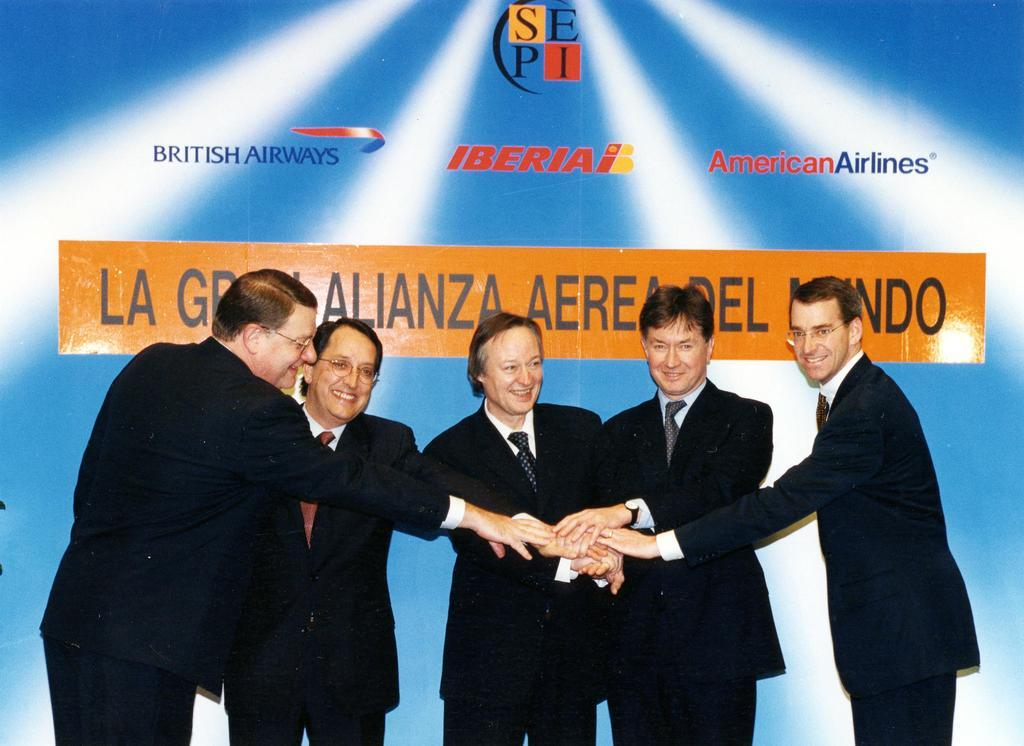What can be seen in the background of the image? There is a hoarding in the background of the image. What are the main subjects in the image? There are men standing in the image. Can you describe the appearance of some of the men? Some of the men are wearing spectacles. What is the general mood of the men in the image? All the men in the image are smiling. What type of boat is being discussed by the men in the image? There is no boat present in the image, nor is there any discussion about a boat. 